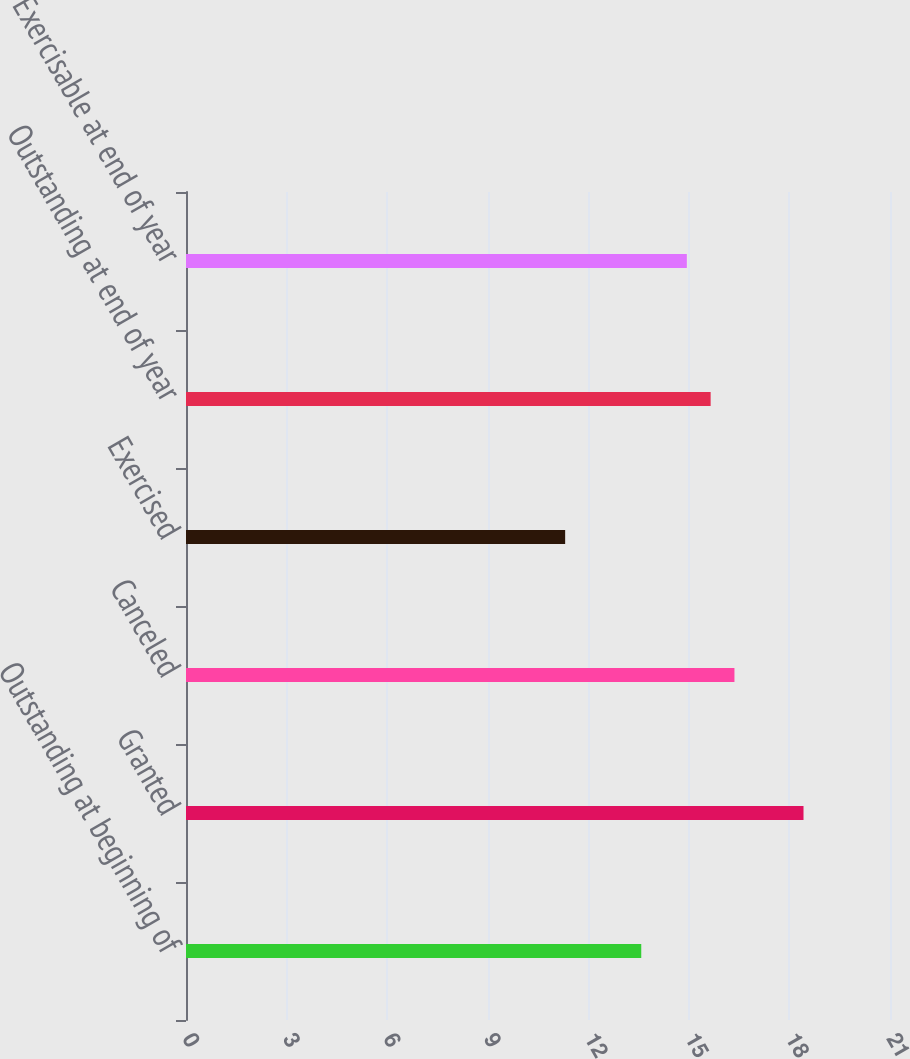<chart> <loc_0><loc_0><loc_500><loc_500><bar_chart><fcel>Outstanding at beginning of<fcel>Granted<fcel>Canceled<fcel>Exercised<fcel>Outstanding at end of year<fcel>Exercisable at end of year<nl><fcel>13.58<fcel>18.42<fcel>16.36<fcel>11.31<fcel>15.65<fcel>14.94<nl></chart> 